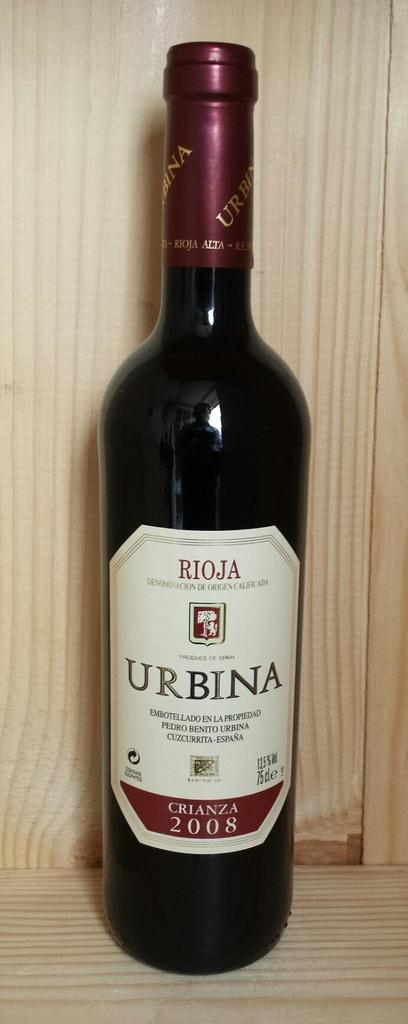<image>
Present a compact description of the photo's key features. A wine bottle label says Rioja and crianza 2008. 